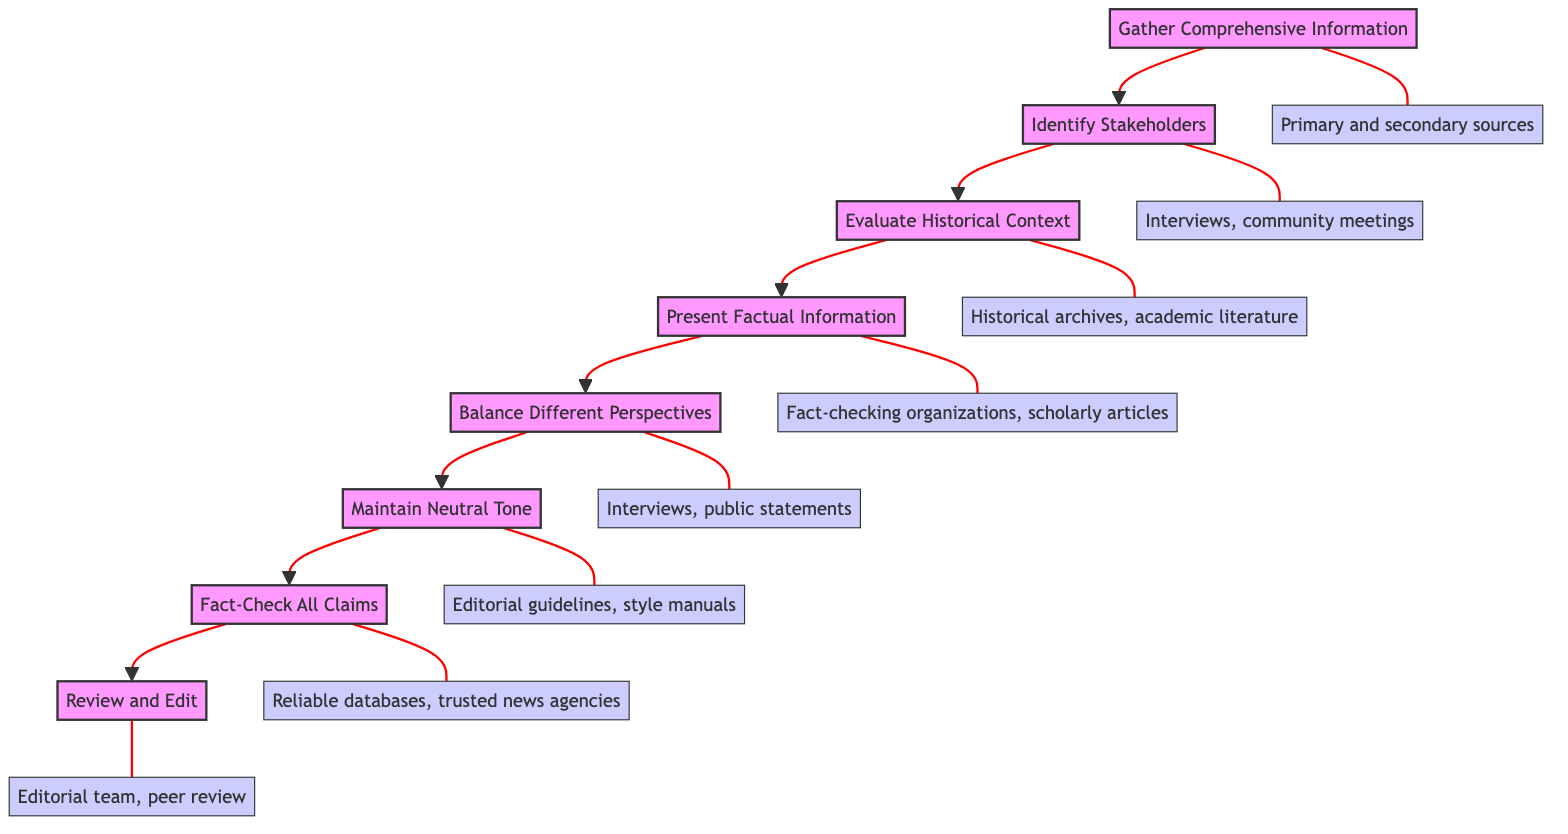What is the first step in the flowchart? The first step in the flowchart is "Gather Comprehensive Information." It is the bottom-most node and does not have any preceding nodes, indicating that it is the initial action in the sequence.
Answer: Gather Comprehensive Information How many nodes are present in the flowchart? There are eight nodes present in the flowchart. Counting each labeled step from the bottom to the top gives us a total of eight distinct actions.
Answer: 8 What is the last step in the flowchart? The last step in the flowchart is "Review and Edit." It is the top-most node in the sequence, signifying that it is the final action to be taken after completing the previous steps.
Answer: Review and Edit What comes after "Maintain Neutral Tone"? "Fact-Check All Claims" comes after "Maintain Neutral Tone." It follows directly in the upward flow of actions, indicating it is the subsequent step.
Answer: Fact-Check All Claims Which node evaluates the historical context? The node that evaluates the historical context is "Evaluate Historical Context." It is positioned above "Identify Stakeholders" in the flowchart and represents a critical analysis step.
Answer: Evaluate Historical Context What sources are used for "Present Factual Information"? The sources used for "Present Factual Information" are "Fact-checking organizations, scholarly articles." This node specifies the type of references needed to ensure the accuracy of the information presented.
Answer: Fact-checking organizations, scholarly articles Which step requires identifying perspectives of key parties? The step that requires identifying perspectives of key parties is "Identify Stakeholders." This step emphasizes understanding who is involved in the controversy surrounding the statues.
Answer: Identify Stakeholders How many edges connect the nodes in the flowchart? There are seven edges connecting the nodes in the flowchart. Each edge represents a directional flow from one step to the next, signifying the relationship between actions.
Answer: 7 What type of information is necessary for "Gather Comprehensive Information"? "Primary and secondary sources" are necessary for "Gather Comprehensive Information." This specifies the kind of references needed to start building a comprehensive view of the topic.
Answer: Primary and secondary sources 